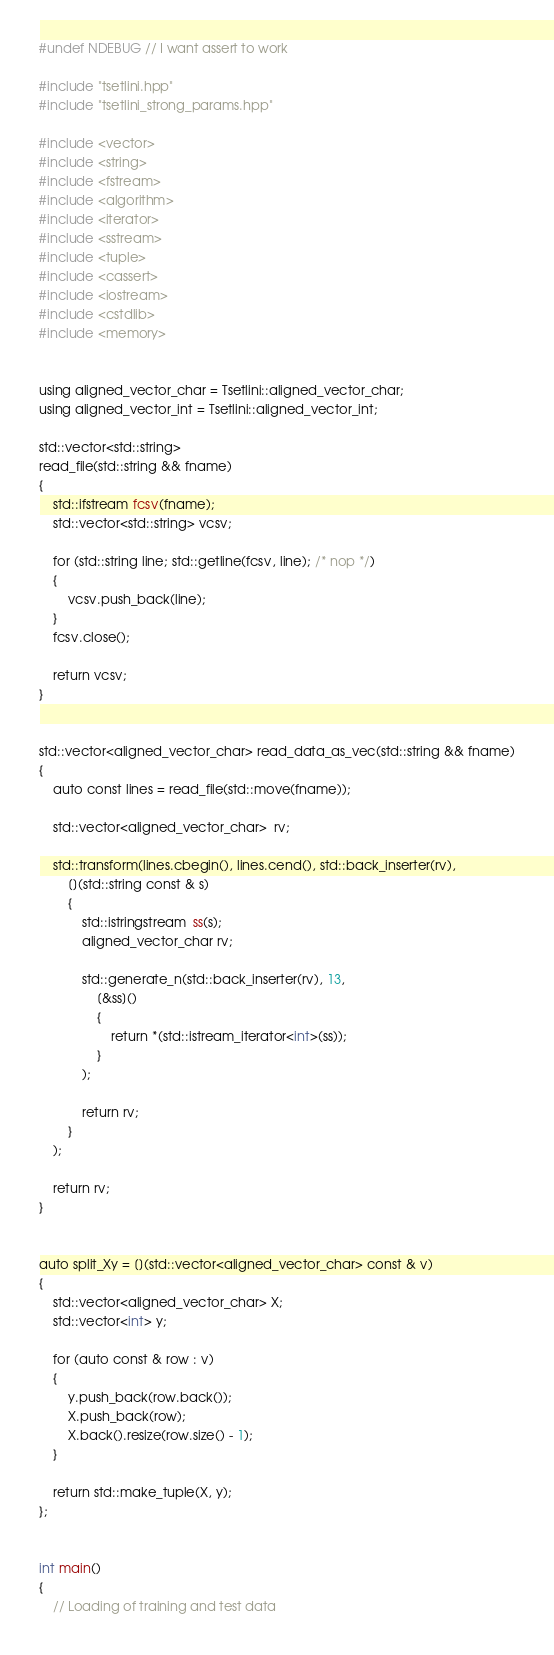Convert code to text. <code><loc_0><loc_0><loc_500><loc_500><_C++_>#undef NDEBUG // I want assert to work

#include "tsetlini.hpp"
#include "tsetlini_strong_params.hpp"

#include <vector>
#include <string>
#include <fstream>
#include <algorithm>
#include <iterator>
#include <sstream>
#include <tuple>
#include <cassert>
#include <iostream>
#include <cstdlib>
#include <memory>


using aligned_vector_char = Tsetlini::aligned_vector_char;
using aligned_vector_int = Tsetlini::aligned_vector_int;

std::vector<std::string>
read_file(std::string && fname)
{
    std::ifstream fcsv(fname);
    std::vector<std::string> vcsv;

    for (std::string line; std::getline(fcsv, line); /* nop */)
    {
        vcsv.push_back(line);
    }
    fcsv.close();

    return vcsv;
}


std::vector<aligned_vector_char> read_data_as_vec(std::string && fname)
{
    auto const lines = read_file(std::move(fname));

    std::vector<aligned_vector_char>  rv;

    std::transform(lines.cbegin(), lines.cend(), std::back_inserter(rv),
        [](std::string const & s)
        {
            std::istringstream  ss(s);
            aligned_vector_char rv;

            std::generate_n(std::back_inserter(rv), 13,
                [&ss]()
                {
                    return *(std::istream_iterator<int>(ss));
                }
            );

            return rv;
        }
    );

    return rv;
}


auto split_Xy = [](std::vector<aligned_vector_char> const & v)
{
    std::vector<aligned_vector_char> X;
    std::vector<int> y;

    for (auto const & row : v)
    {
        y.push_back(row.back());
        X.push_back(row);
        X.back().resize(row.size() - 1);
    }

    return std::make_tuple(X, y);
};


int main()
{
    // Loading of training and test data</code> 